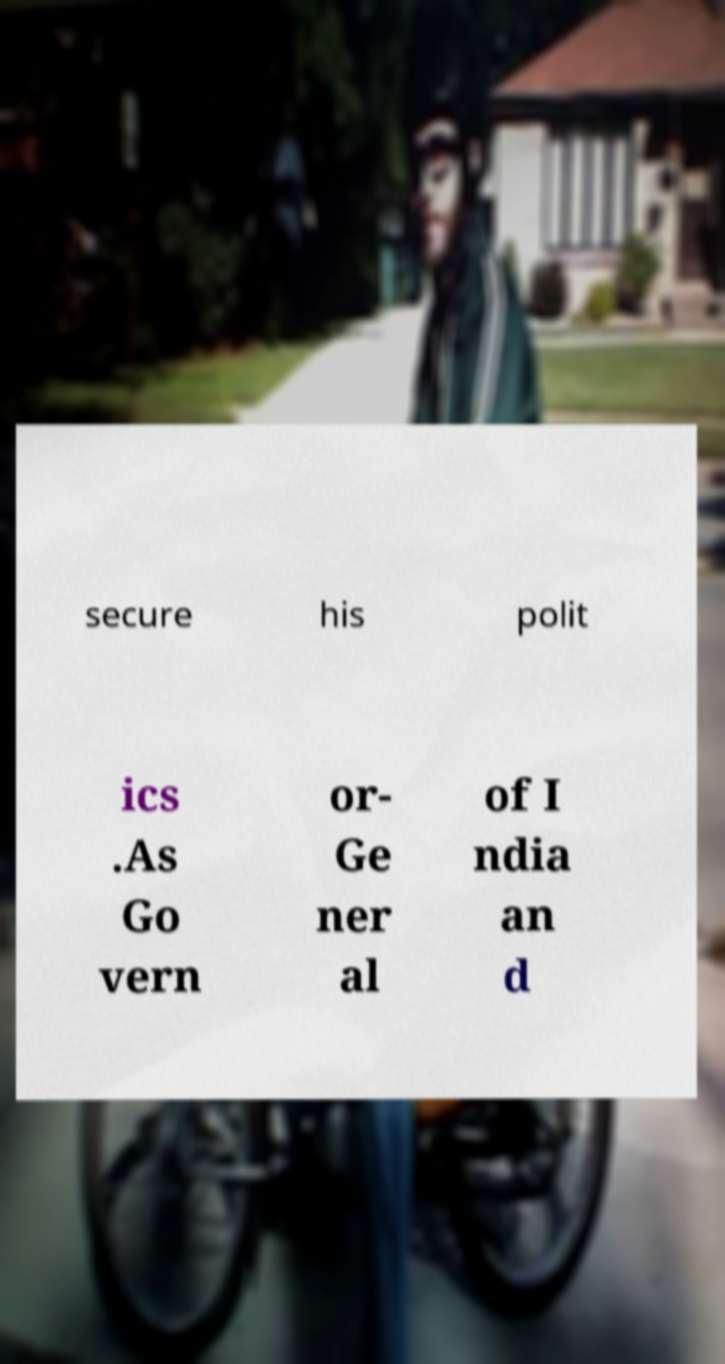Please identify and transcribe the text found in this image. secure his polit ics .As Go vern or- Ge ner al of I ndia an d 